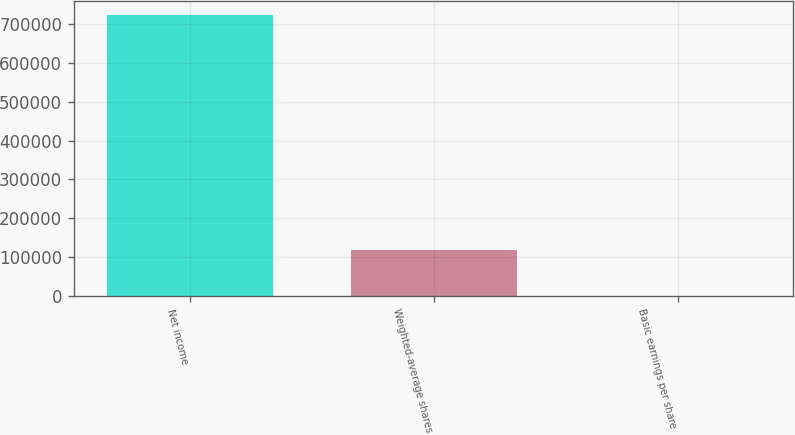Convert chart. <chart><loc_0><loc_0><loc_500><loc_500><bar_chart><fcel>Net income<fcel>Weighted-average shares<fcel>Basic earnings per share<nl><fcel>722521<fcel>117696<fcel>6.14<nl></chart> 